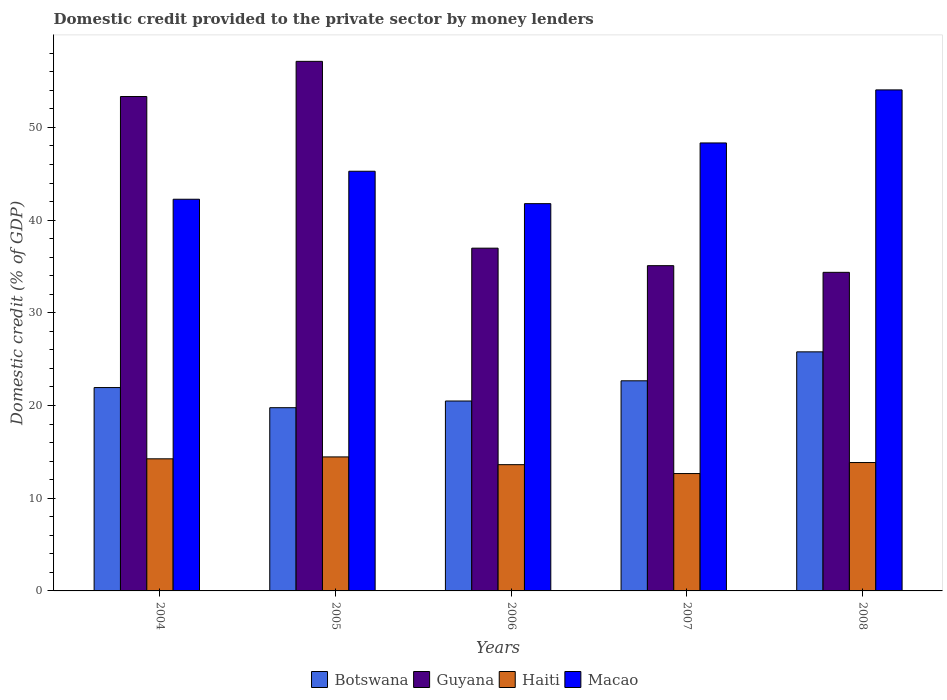How many different coloured bars are there?
Give a very brief answer. 4. Are the number of bars on each tick of the X-axis equal?
Your answer should be compact. Yes. How many bars are there on the 5th tick from the left?
Offer a terse response. 4. In how many cases, is the number of bars for a given year not equal to the number of legend labels?
Provide a succinct answer. 0. What is the domestic credit provided to the private sector by money lenders in Guyana in 2008?
Your response must be concise. 34.36. Across all years, what is the maximum domestic credit provided to the private sector by money lenders in Macao?
Offer a terse response. 54.04. Across all years, what is the minimum domestic credit provided to the private sector by money lenders in Botswana?
Provide a succinct answer. 19.76. In which year was the domestic credit provided to the private sector by money lenders in Guyana maximum?
Make the answer very short. 2005. What is the total domestic credit provided to the private sector by money lenders in Botswana in the graph?
Provide a succinct answer. 110.64. What is the difference between the domestic credit provided to the private sector by money lenders in Guyana in 2007 and that in 2008?
Your response must be concise. 0.72. What is the difference between the domestic credit provided to the private sector by money lenders in Macao in 2008 and the domestic credit provided to the private sector by money lenders in Guyana in 2004?
Provide a succinct answer. 0.71. What is the average domestic credit provided to the private sector by money lenders in Guyana per year?
Your answer should be compact. 43.37. In the year 2008, what is the difference between the domestic credit provided to the private sector by money lenders in Macao and domestic credit provided to the private sector by money lenders in Botswana?
Provide a short and direct response. 28.26. What is the ratio of the domestic credit provided to the private sector by money lenders in Botswana in 2005 to that in 2008?
Give a very brief answer. 0.77. Is the domestic credit provided to the private sector by money lenders in Botswana in 2005 less than that in 2007?
Ensure brevity in your answer.  Yes. What is the difference between the highest and the second highest domestic credit provided to the private sector by money lenders in Haiti?
Provide a succinct answer. 0.21. What is the difference between the highest and the lowest domestic credit provided to the private sector by money lenders in Guyana?
Offer a very short reply. 22.76. Is the sum of the domestic credit provided to the private sector by money lenders in Macao in 2004 and 2005 greater than the maximum domestic credit provided to the private sector by money lenders in Guyana across all years?
Your response must be concise. Yes. What does the 4th bar from the left in 2005 represents?
Your answer should be compact. Macao. What does the 2nd bar from the right in 2006 represents?
Give a very brief answer. Haiti. How many bars are there?
Give a very brief answer. 20. Are all the bars in the graph horizontal?
Your response must be concise. No. How many years are there in the graph?
Your answer should be very brief. 5. What is the difference between two consecutive major ticks on the Y-axis?
Make the answer very short. 10. Does the graph contain any zero values?
Keep it short and to the point. No. Does the graph contain grids?
Your answer should be compact. No. Where does the legend appear in the graph?
Provide a succinct answer. Bottom center. What is the title of the graph?
Offer a terse response. Domestic credit provided to the private sector by money lenders. Does "Samoa" appear as one of the legend labels in the graph?
Make the answer very short. No. What is the label or title of the X-axis?
Give a very brief answer. Years. What is the label or title of the Y-axis?
Your response must be concise. Domestic credit (% of GDP). What is the Domestic credit (% of GDP) in Botswana in 2004?
Offer a very short reply. 21.94. What is the Domestic credit (% of GDP) of Guyana in 2004?
Your answer should be very brief. 53.33. What is the Domestic credit (% of GDP) of Haiti in 2004?
Offer a very short reply. 14.25. What is the Domestic credit (% of GDP) of Macao in 2004?
Offer a terse response. 42.25. What is the Domestic credit (% of GDP) in Botswana in 2005?
Give a very brief answer. 19.76. What is the Domestic credit (% of GDP) in Guyana in 2005?
Give a very brief answer. 57.12. What is the Domestic credit (% of GDP) in Haiti in 2005?
Provide a succinct answer. 14.45. What is the Domestic credit (% of GDP) in Macao in 2005?
Provide a short and direct response. 45.27. What is the Domestic credit (% of GDP) in Botswana in 2006?
Keep it short and to the point. 20.48. What is the Domestic credit (% of GDP) in Guyana in 2006?
Give a very brief answer. 36.97. What is the Domestic credit (% of GDP) of Haiti in 2006?
Offer a very short reply. 13.62. What is the Domestic credit (% of GDP) of Macao in 2006?
Your response must be concise. 41.77. What is the Domestic credit (% of GDP) in Botswana in 2007?
Give a very brief answer. 22.66. What is the Domestic credit (% of GDP) of Guyana in 2007?
Ensure brevity in your answer.  35.08. What is the Domestic credit (% of GDP) of Haiti in 2007?
Provide a short and direct response. 12.66. What is the Domestic credit (% of GDP) of Macao in 2007?
Your response must be concise. 48.32. What is the Domestic credit (% of GDP) in Botswana in 2008?
Provide a short and direct response. 25.79. What is the Domestic credit (% of GDP) in Guyana in 2008?
Offer a very short reply. 34.36. What is the Domestic credit (% of GDP) of Haiti in 2008?
Your response must be concise. 13.85. What is the Domestic credit (% of GDP) of Macao in 2008?
Provide a succinct answer. 54.04. Across all years, what is the maximum Domestic credit (% of GDP) in Botswana?
Ensure brevity in your answer.  25.79. Across all years, what is the maximum Domestic credit (% of GDP) in Guyana?
Your answer should be very brief. 57.12. Across all years, what is the maximum Domestic credit (% of GDP) in Haiti?
Your response must be concise. 14.45. Across all years, what is the maximum Domestic credit (% of GDP) in Macao?
Make the answer very short. 54.04. Across all years, what is the minimum Domestic credit (% of GDP) of Botswana?
Keep it short and to the point. 19.76. Across all years, what is the minimum Domestic credit (% of GDP) of Guyana?
Your response must be concise. 34.36. Across all years, what is the minimum Domestic credit (% of GDP) of Haiti?
Your answer should be very brief. 12.66. Across all years, what is the minimum Domestic credit (% of GDP) of Macao?
Offer a terse response. 41.77. What is the total Domestic credit (% of GDP) in Botswana in the graph?
Make the answer very short. 110.64. What is the total Domestic credit (% of GDP) in Guyana in the graph?
Give a very brief answer. 216.87. What is the total Domestic credit (% of GDP) in Haiti in the graph?
Your response must be concise. 68.83. What is the total Domestic credit (% of GDP) of Macao in the graph?
Your response must be concise. 231.66. What is the difference between the Domestic credit (% of GDP) in Botswana in 2004 and that in 2005?
Your response must be concise. 2.17. What is the difference between the Domestic credit (% of GDP) of Guyana in 2004 and that in 2005?
Make the answer very short. -3.79. What is the difference between the Domestic credit (% of GDP) of Haiti in 2004 and that in 2005?
Your answer should be compact. -0.21. What is the difference between the Domestic credit (% of GDP) of Macao in 2004 and that in 2005?
Your response must be concise. -3.02. What is the difference between the Domestic credit (% of GDP) in Botswana in 2004 and that in 2006?
Your answer should be compact. 1.45. What is the difference between the Domestic credit (% of GDP) of Guyana in 2004 and that in 2006?
Provide a short and direct response. 16.36. What is the difference between the Domestic credit (% of GDP) in Haiti in 2004 and that in 2006?
Your answer should be very brief. 0.63. What is the difference between the Domestic credit (% of GDP) in Macao in 2004 and that in 2006?
Make the answer very short. 0.48. What is the difference between the Domestic credit (% of GDP) in Botswana in 2004 and that in 2007?
Your answer should be very brief. -0.73. What is the difference between the Domestic credit (% of GDP) of Guyana in 2004 and that in 2007?
Provide a succinct answer. 18.25. What is the difference between the Domestic credit (% of GDP) of Haiti in 2004 and that in 2007?
Your answer should be very brief. 1.59. What is the difference between the Domestic credit (% of GDP) of Macao in 2004 and that in 2007?
Offer a very short reply. -6.07. What is the difference between the Domestic credit (% of GDP) of Botswana in 2004 and that in 2008?
Your answer should be compact. -3.85. What is the difference between the Domestic credit (% of GDP) of Guyana in 2004 and that in 2008?
Give a very brief answer. 18.97. What is the difference between the Domestic credit (% of GDP) in Haiti in 2004 and that in 2008?
Your answer should be compact. 0.4. What is the difference between the Domestic credit (% of GDP) in Macao in 2004 and that in 2008?
Your answer should be compact. -11.79. What is the difference between the Domestic credit (% of GDP) of Botswana in 2005 and that in 2006?
Provide a succinct answer. -0.72. What is the difference between the Domestic credit (% of GDP) in Guyana in 2005 and that in 2006?
Your answer should be compact. 20.15. What is the difference between the Domestic credit (% of GDP) of Haiti in 2005 and that in 2006?
Give a very brief answer. 0.84. What is the difference between the Domestic credit (% of GDP) in Macao in 2005 and that in 2006?
Make the answer very short. 3.5. What is the difference between the Domestic credit (% of GDP) in Botswana in 2005 and that in 2007?
Provide a short and direct response. -2.9. What is the difference between the Domestic credit (% of GDP) in Guyana in 2005 and that in 2007?
Make the answer very short. 22.04. What is the difference between the Domestic credit (% of GDP) in Haiti in 2005 and that in 2007?
Your response must be concise. 1.8. What is the difference between the Domestic credit (% of GDP) of Macao in 2005 and that in 2007?
Provide a succinct answer. -3.05. What is the difference between the Domestic credit (% of GDP) in Botswana in 2005 and that in 2008?
Offer a very short reply. -6.02. What is the difference between the Domestic credit (% of GDP) in Guyana in 2005 and that in 2008?
Keep it short and to the point. 22.76. What is the difference between the Domestic credit (% of GDP) in Haiti in 2005 and that in 2008?
Give a very brief answer. 0.61. What is the difference between the Domestic credit (% of GDP) of Macao in 2005 and that in 2008?
Provide a short and direct response. -8.77. What is the difference between the Domestic credit (% of GDP) of Botswana in 2006 and that in 2007?
Your answer should be compact. -2.18. What is the difference between the Domestic credit (% of GDP) in Guyana in 2006 and that in 2007?
Your answer should be very brief. 1.89. What is the difference between the Domestic credit (% of GDP) in Haiti in 2006 and that in 2007?
Offer a very short reply. 0.96. What is the difference between the Domestic credit (% of GDP) of Macao in 2006 and that in 2007?
Make the answer very short. -6.55. What is the difference between the Domestic credit (% of GDP) of Botswana in 2006 and that in 2008?
Keep it short and to the point. -5.3. What is the difference between the Domestic credit (% of GDP) of Guyana in 2006 and that in 2008?
Offer a terse response. 2.61. What is the difference between the Domestic credit (% of GDP) in Haiti in 2006 and that in 2008?
Give a very brief answer. -0.23. What is the difference between the Domestic credit (% of GDP) of Macao in 2006 and that in 2008?
Your answer should be compact. -12.27. What is the difference between the Domestic credit (% of GDP) of Botswana in 2007 and that in 2008?
Provide a short and direct response. -3.12. What is the difference between the Domestic credit (% of GDP) in Guyana in 2007 and that in 2008?
Offer a terse response. 0.72. What is the difference between the Domestic credit (% of GDP) of Haiti in 2007 and that in 2008?
Your response must be concise. -1.19. What is the difference between the Domestic credit (% of GDP) of Macao in 2007 and that in 2008?
Provide a short and direct response. -5.72. What is the difference between the Domestic credit (% of GDP) of Botswana in 2004 and the Domestic credit (% of GDP) of Guyana in 2005?
Keep it short and to the point. -35.19. What is the difference between the Domestic credit (% of GDP) of Botswana in 2004 and the Domestic credit (% of GDP) of Haiti in 2005?
Give a very brief answer. 7.48. What is the difference between the Domestic credit (% of GDP) in Botswana in 2004 and the Domestic credit (% of GDP) in Macao in 2005?
Make the answer very short. -23.33. What is the difference between the Domestic credit (% of GDP) of Guyana in 2004 and the Domestic credit (% of GDP) of Haiti in 2005?
Provide a succinct answer. 38.87. What is the difference between the Domestic credit (% of GDP) in Guyana in 2004 and the Domestic credit (% of GDP) in Macao in 2005?
Keep it short and to the point. 8.06. What is the difference between the Domestic credit (% of GDP) in Haiti in 2004 and the Domestic credit (% of GDP) in Macao in 2005?
Give a very brief answer. -31.02. What is the difference between the Domestic credit (% of GDP) of Botswana in 2004 and the Domestic credit (% of GDP) of Guyana in 2006?
Your answer should be compact. -15.04. What is the difference between the Domestic credit (% of GDP) in Botswana in 2004 and the Domestic credit (% of GDP) in Haiti in 2006?
Make the answer very short. 8.32. What is the difference between the Domestic credit (% of GDP) of Botswana in 2004 and the Domestic credit (% of GDP) of Macao in 2006?
Ensure brevity in your answer.  -19.84. What is the difference between the Domestic credit (% of GDP) of Guyana in 2004 and the Domestic credit (% of GDP) of Haiti in 2006?
Give a very brief answer. 39.71. What is the difference between the Domestic credit (% of GDP) in Guyana in 2004 and the Domestic credit (% of GDP) in Macao in 2006?
Give a very brief answer. 11.56. What is the difference between the Domestic credit (% of GDP) of Haiti in 2004 and the Domestic credit (% of GDP) of Macao in 2006?
Offer a very short reply. -27.52. What is the difference between the Domestic credit (% of GDP) of Botswana in 2004 and the Domestic credit (% of GDP) of Guyana in 2007?
Provide a short and direct response. -13.15. What is the difference between the Domestic credit (% of GDP) in Botswana in 2004 and the Domestic credit (% of GDP) in Haiti in 2007?
Your answer should be very brief. 9.28. What is the difference between the Domestic credit (% of GDP) in Botswana in 2004 and the Domestic credit (% of GDP) in Macao in 2007?
Offer a terse response. -26.39. What is the difference between the Domestic credit (% of GDP) of Guyana in 2004 and the Domestic credit (% of GDP) of Haiti in 2007?
Make the answer very short. 40.67. What is the difference between the Domestic credit (% of GDP) in Guyana in 2004 and the Domestic credit (% of GDP) in Macao in 2007?
Keep it short and to the point. 5.01. What is the difference between the Domestic credit (% of GDP) in Haiti in 2004 and the Domestic credit (% of GDP) in Macao in 2007?
Offer a terse response. -34.07. What is the difference between the Domestic credit (% of GDP) in Botswana in 2004 and the Domestic credit (% of GDP) in Guyana in 2008?
Your response must be concise. -12.43. What is the difference between the Domestic credit (% of GDP) in Botswana in 2004 and the Domestic credit (% of GDP) in Haiti in 2008?
Your response must be concise. 8.09. What is the difference between the Domestic credit (% of GDP) in Botswana in 2004 and the Domestic credit (% of GDP) in Macao in 2008?
Offer a terse response. -32.11. What is the difference between the Domestic credit (% of GDP) in Guyana in 2004 and the Domestic credit (% of GDP) in Haiti in 2008?
Provide a short and direct response. 39.48. What is the difference between the Domestic credit (% of GDP) in Guyana in 2004 and the Domestic credit (% of GDP) in Macao in 2008?
Offer a terse response. -0.71. What is the difference between the Domestic credit (% of GDP) of Haiti in 2004 and the Domestic credit (% of GDP) of Macao in 2008?
Make the answer very short. -39.79. What is the difference between the Domestic credit (% of GDP) in Botswana in 2005 and the Domestic credit (% of GDP) in Guyana in 2006?
Make the answer very short. -17.21. What is the difference between the Domestic credit (% of GDP) in Botswana in 2005 and the Domestic credit (% of GDP) in Haiti in 2006?
Ensure brevity in your answer.  6.14. What is the difference between the Domestic credit (% of GDP) of Botswana in 2005 and the Domestic credit (% of GDP) of Macao in 2006?
Offer a terse response. -22.01. What is the difference between the Domestic credit (% of GDP) of Guyana in 2005 and the Domestic credit (% of GDP) of Haiti in 2006?
Ensure brevity in your answer.  43.5. What is the difference between the Domestic credit (% of GDP) of Guyana in 2005 and the Domestic credit (% of GDP) of Macao in 2006?
Make the answer very short. 15.35. What is the difference between the Domestic credit (% of GDP) of Haiti in 2005 and the Domestic credit (% of GDP) of Macao in 2006?
Offer a terse response. -27.32. What is the difference between the Domestic credit (% of GDP) in Botswana in 2005 and the Domestic credit (% of GDP) in Guyana in 2007?
Your answer should be compact. -15.32. What is the difference between the Domestic credit (% of GDP) in Botswana in 2005 and the Domestic credit (% of GDP) in Haiti in 2007?
Keep it short and to the point. 7.1. What is the difference between the Domestic credit (% of GDP) in Botswana in 2005 and the Domestic credit (% of GDP) in Macao in 2007?
Provide a succinct answer. -28.56. What is the difference between the Domestic credit (% of GDP) in Guyana in 2005 and the Domestic credit (% of GDP) in Haiti in 2007?
Keep it short and to the point. 44.46. What is the difference between the Domestic credit (% of GDP) in Guyana in 2005 and the Domestic credit (% of GDP) in Macao in 2007?
Ensure brevity in your answer.  8.8. What is the difference between the Domestic credit (% of GDP) in Haiti in 2005 and the Domestic credit (% of GDP) in Macao in 2007?
Your response must be concise. -33.87. What is the difference between the Domestic credit (% of GDP) of Botswana in 2005 and the Domestic credit (% of GDP) of Guyana in 2008?
Ensure brevity in your answer.  -14.6. What is the difference between the Domestic credit (% of GDP) of Botswana in 2005 and the Domestic credit (% of GDP) of Haiti in 2008?
Your answer should be compact. 5.92. What is the difference between the Domestic credit (% of GDP) of Botswana in 2005 and the Domestic credit (% of GDP) of Macao in 2008?
Your response must be concise. -34.28. What is the difference between the Domestic credit (% of GDP) of Guyana in 2005 and the Domestic credit (% of GDP) of Haiti in 2008?
Your response must be concise. 43.28. What is the difference between the Domestic credit (% of GDP) of Guyana in 2005 and the Domestic credit (% of GDP) of Macao in 2008?
Provide a short and direct response. 3.08. What is the difference between the Domestic credit (% of GDP) of Haiti in 2005 and the Domestic credit (% of GDP) of Macao in 2008?
Your response must be concise. -39.59. What is the difference between the Domestic credit (% of GDP) in Botswana in 2006 and the Domestic credit (% of GDP) in Guyana in 2007?
Make the answer very short. -14.6. What is the difference between the Domestic credit (% of GDP) of Botswana in 2006 and the Domestic credit (% of GDP) of Haiti in 2007?
Provide a short and direct response. 7.82. What is the difference between the Domestic credit (% of GDP) of Botswana in 2006 and the Domestic credit (% of GDP) of Macao in 2007?
Offer a very short reply. -27.84. What is the difference between the Domestic credit (% of GDP) of Guyana in 2006 and the Domestic credit (% of GDP) of Haiti in 2007?
Ensure brevity in your answer.  24.31. What is the difference between the Domestic credit (% of GDP) in Guyana in 2006 and the Domestic credit (% of GDP) in Macao in 2007?
Keep it short and to the point. -11.35. What is the difference between the Domestic credit (% of GDP) in Haiti in 2006 and the Domestic credit (% of GDP) in Macao in 2007?
Offer a very short reply. -34.7. What is the difference between the Domestic credit (% of GDP) of Botswana in 2006 and the Domestic credit (% of GDP) of Guyana in 2008?
Ensure brevity in your answer.  -13.88. What is the difference between the Domestic credit (% of GDP) of Botswana in 2006 and the Domestic credit (% of GDP) of Haiti in 2008?
Offer a terse response. 6.64. What is the difference between the Domestic credit (% of GDP) in Botswana in 2006 and the Domestic credit (% of GDP) in Macao in 2008?
Your answer should be very brief. -33.56. What is the difference between the Domestic credit (% of GDP) of Guyana in 2006 and the Domestic credit (% of GDP) of Haiti in 2008?
Your response must be concise. 23.13. What is the difference between the Domestic credit (% of GDP) of Guyana in 2006 and the Domestic credit (% of GDP) of Macao in 2008?
Provide a succinct answer. -17.07. What is the difference between the Domestic credit (% of GDP) in Haiti in 2006 and the Domestic credit (% of GDP) in Macao in 2008?
Make the answer very short. -40.42. What is the difference between the Domestic credit (% of GDP) of Botswana in 2007 and the Domestic credit (% of GDP) of Guyana in 2008?
Your answer should be compact. -11.7. What is the difference between the Domestic credit (% of GDP) of Botswana in 2007 and the Domestic credit (% of GDP) of Haiti in 2008?
Keep it short and to the point. 8.82. What is the difference between the Domestic credit (% of GDP) in Botswana in 2007 and the Domestic credit (% of GDP) in Macao in 2008?
Your answer should be compact. -31.38. What is the difference between the Domestic credit (% of GDP) of Guyana in 2007 and the Domestic credit (% of GDP) of Haiti in 2008?
Provide a short and direct response. 21.24. What is the difference between the Domestic credit (% of GDP) of Guyana in 2007 and the Domestic credit (% of GDP) of Macao in 2008?
Your response must be concise. -18.96. What is the difference between the Domestic credit (% of GDP) in Haiti in 2007 and the Domestic credit (% of GDP) in Macao in 2008?
Your answer should be compact. -41.38. What is the average Domestic credit (% of GDP) of Botswana per year?
Provide a short and direct response. 22.13. What is the average Domestic credit (% of GDP) of Guyana per year?
Your answer should be compact. 43.37. What is the average Domestic credit (% of GDP) in Haiti per year?
Ensure brevity in your answer.  13.77. What is the average Domestic credit (% of GDP) of Macao per year?
Your answer should be very brief. 46.33. In the year 2004, what is the difference between the Domestic credit (% of GDP) of Botswana and Domestic credit (% of GDP) of Guyana?
Your answer should be very brief. -31.39. In the year 2004, what is the difference between the Domestic credit (% of GDP) in Botswana and Domestic credit (% of GDP) in Haiti?
Provide a succinct answer. 7.69. In the year 2004, what is the difference between the Domestic credit (% of GDP) of Botswana and Domestic credit (% of GDP) of Macao?
Make the answer very short. -20.31. In the year 2004, what is the difference between the Domestic credit (% of GDP) in Guyana and Domestic credit (% of GDP) in Haiti?
Offer a terse response. 39.08. In the year 2004, what is the difference between the Domestic credit (% of GDP) of Guyana and Domestic credit (% of GDP) of Macao?
Provide a succinct answer. 11.08. In the year 2004, what is the difference between the Domestic credit (% of GDP) in Haiti and Domestic credit (% of GDP) in Macao?
Provide a succinct answer. -28. In the year 2005, what is the difference between the Domestic credit (% of GDP) of Botswana and Domestic credit (% of GDP) of Guyana?
Offer a terse response. -37.36. In the year 2005, what is the difference between the Domestic credit (% of GDP) in Botswana and Domestic credit (% of GDP) in Haiti?
Make the answer very short. 5.31. In the year 2005, what is the difference between the Domestic credit (% of GDP) of Botswana and Domestic credit (% of GDP) of Macao?
Offer a very short reply. -25.51. In the year 2005, what is the difference between the Domestic credit (% of GDP) in Guyana and Domestic credit (% of GDP) in Haiti?
Provide a succinct answer. 42.67. In the year 2005, what is the difference between the Domestic credit (% of GDP) of Guyana and Domestic credit (% of GDP) of Macao?
Give a very brief answer. 11.85. In the year 2005, what is the difference between the Domestic credit (% of GDP) in Haiti and Domestic credit (% of GDP) in Macao?
Give a very brief answer. -30.81. In the year 2006, what is the difference between the Domestic credit (% of GDP) in Botswana and Domestic credit (% of GDP) in Guyana?
Your response must be concise. -16.49. In the year 2006, what is the difference between the Domestic credit (% of GDP) of Botswana and Domestic credit (% of GDP) of Haiti?
Provide a short and direct response. 6.87. In the year 2006, what is the difference between the Domestic credit (% of GDP) in Botswana and Domestic credit (% of GDP) in Macao?
Your answer should be compact. -21.29. In the year 2006, what is the difference between the Domestic credit (% of GDP) in Guyana and Domestic credit (% of GDP) in Haiti?
Your answer should be compact. 23.35. In the year 2006, what is the difference between the Domestic credit (% of GDP) in Guyana and Domestic credit (% of GDP) in Macao?
Provide a short and direct response. -4.8. In the year 2006, what is the difference between the Domestic credit (% of GDP) in Haiti and Domestic credit (% of GDP) in Macao?
Your response must be concise. -28.15. In the year 2007, what is the difference between the Domestic credit (% of GDP) in Botswana and Domestic credit (% of GDP) in Guyana?
Make the answer very short. -12.42. In the year 2007, what is the difference between the Domestic credit (% of GDP) in Botswana and Domestic credit (% of GDP) in Haiti?
Provide a succinct answer. 10. In the year 2007, what is the difference between the Domestic credit (% of GDP) in Botswana and Domestic credit (% of GDP) in Macao?
Ensure brevity in your answer.  -25.66. In the year 2007, what is the difference between the Domestic credit (% of GDP) of Guyana and Domestic credit (% of GDP) of Haiti?
Offer a very short reply. 22.42. In the year 2007, what is the difference between the Domestic credit (% of GDP) in Guyana and Domestic credit (% of GDP) in Macao?
Provide a short and direct response. -13.24. In the year 2007, what is the difference between the Domestic credit (% of GDP) in Haiti and Domestic credit (% of GDP) in Macao?
Provide a succinct answer. -35.66. In the year 2008, what is the difference between the Domestic credit (% of GDP) of Botswana and Domestic credit (% of GDP) of Guyana?
Your response must be concise. -8.58. In the year 2008, what is the difference between the Domestic credit (% of GDP) of Botswana and Domestic credit (% of GDP) of Haiti?
Keep it short and to the point. 11.94. In the year 2008, what is the difference between the Domestic credit (% of GDP) in Botswana and Domestic credit (% of GDP) in Macao?
Provide a succinct answer. -28.26. In the year 2008, what is the difference between the Domestic credit (% of GDP) in Guyana and Domestic credit (% of GDP) in Haiti?
Your answer should be compact. 20.52. In the year 2008, what is the difference between the Domestic credit (% of GDP) in Guyana and Domestic credit (% of GDP) in Macao?
Make the answer very short. -19.68. In the year 2008, what is the difference between the Domestic credit (% of GDP) in Haiti and Domestic credit (% of GDP) in Macao?
Provide a short and direct response. -40.2. What is the ratio of the Domestic credit (% of GDP) in Botswana in 2004 to that in 2005?
Your answer should be compact. 1.11. What is the ratio of the Domestic credit (% of GDP) in Guyana in 2004 to that in 2005?
Your answer should be very brief. 0.93. What is the ratio of the Domestic credit (% of GDP) of Haiti in 2004 to that in 2005?
Ensure brevity in your answer.  0.99. What is the ratio of the Domestic credit (% of GDP) in Botswana in 2004 to that in 2006?
Give a very brief answer. 1.07. What is the ratio of the Domestic credit (% of GDP) of Guyana in 2004 to that in 2006?
Your answer should be very brief. 1.44. What is the ratio of the Domestic credit (% of GDP) in Haiti in 2004 to that in 2006?
Make the answer very short. 1.05. What is the ratio of the Domestic credit (% of GDP) of Macao in 2004 to that in 2006?
Provide a succinct answer. 1.01. What is the ratio of the Domestic credit (% of GDP) of Botswana in 2004 to that in 2007?
Offer a terse response. 0.97. What is the ratio of the Domestic credit (% of GDP) in Guyana in 2004 to that in 2007?
Your answer should be very brief. 1.52. What is the ratio of the Domestic credit (% of GDP) of Haiti in 2004 to that in 2007?
Ensure brevity in your answer.  1.13. What is the ratio of the Domestic credit (% of GDP) of Macao in 2004 to that in 2007?
Keep it short and to the point. 0.87. What is the ratio of the Domestic credit (% of GDP) of Botswana in 2004 to that in 2008?
Offer a very short reply. 0.85. What is the ratio of the Domestic credit (% of GDP) in Guyana in 2004 to that in 2008?
Provide a short and direct response. 1.55. What is the ratio of the Domestic credit (% of GDP) in Haiti in 2004 to that in 2008?
Your answer should be very brief. 1.03. What is the ratio of the Domestic credit (% of GDP) in Macao in 2004 to that in 2008?
Offer a terse response. 0.78. What is the ratio of the Domestic credit (% of GDP) of Botswana in 2005 to that in 2006?
Keep it short and to the point. 0.96. What is the ratio of the Domestic credit (% of GDP) in Guyana in 2005 to that in 2006?
Give a very brief answer. 1.54. What is the ratio of the Domestic credit (% of GDP) of Haiti in 2005 to that in 2006?
Keep it short and to the point. 1.06. What is the ratio of the Domestic credit (% of GDP) in Macao in 2005 to that in 2006?
Your response must be concise. 1.08. What is the ratio of the Domestic credit (% of GDP) of Botswana in 2005 to that in 2007?
Provide a succinct answer. 0.87. What is the ratio of the Domestic credit (% of GDP) in Guyana in 2005 to that in 2007?
Provide a short and direct response. 1.63. What is the ratio of the Domestic credit (% of GDP) in Haiti in 2005 to that in 2007?
Provide a succinct answer. 1.14. What is the ratio of the Domestic credit (% of GDP) in Macao in 2005 to that in 2007?
Keep it short and to the point. 0.94. What is the ratio of the Domestic credit (% of GDP) of Botswana in 2005 to that in 2008?
Your answer should be very brief. 0.77. What is the ratio of the Domestic credit (% of GDP) in Guyana in 2005 to that in 2008?
Your answer should be compact. 1.66. What is the ratio of the Domestic credit (% of GDP) of Haiti in 2005 to that in 2008?
Offer a very short reply. 1.04. What is the ratio of the Domestic credit (% of GDP) in Macao in 2005 to that in 2008?
Provide a succinct answer. 0.84. What is the ratio of the Domestic credit (% of GDP) of Botswana in 2006 to that in 2007?
Offer a very short reply. 0.9. What is the ratio of the Domestic credit (% of GDP) of Guyana in 2006 to that in 2007?
Offer a very short reply. 1.05. What is the ratio of the Domestic credit (% of GDP) in Haiti in 2006 to that in 2007?
Keep it short and to the point. 1.08. What is the ratio of the Domestic credit (% of GDP) of Macao in 2006 to that in 2007?
Ensure brevity in your answer.  0.86. What is the ratio of the Domestic credit (% of GDP) in Botswana in 2006 to that in 2008?
Provide a succinct answer. 0.79. What is the ratio of the Domestic credit (% of GDP) of Guyana in 2006 to that in 2008?
Make the answer very short. 1.08. What is the ratio of the Domestic credit (% of GDP) in Haiti in 2006 to that in 2008?
Your answer should be very brief. 0.98. What is the ratio of the Domestic credit (% of GDP) in Macao in 2006 to that in 2008?
Make the answer very short. 0.77. What is the ratio of the Domestic credit (% of GDP) in Botswana in 2007 to that in 2008?
Keep it short and to the point. 0.88. What is the ratio of the Domestic credit (% of GDP) in Guyana in 2007 to that in 2008?
Your response must be concise. 1.02. What is the ratio of the Domestic credit (% of GDP) of Haiti in 2007 to that in 2008?
Your answer should be compact. 0.91. What is the ratio of the Domestic credit (% of GDP) in Macao in 2007 to that in 2008?
Give a very brief answer. 0.89. What is the difference between the highest and the second highest Domestic credit (% of GDP) of Botswana?
Make the answer very short. 3.12. What is the difference between the highest and the second highest Domestic credit (% of GDP) in Guyana?
Provide a succinct answer. 3.79. What is the difference between the highest and the second highest Domestic credit (% of GDP) in Haiti?
Make the answer very short. 0.21. What is the difference between the highest and the second highest Domestic credit (% of GDP) of Macao?
Your response must be concise. 5.72. What is the difference between the highest and the lowest Domestic credit (% of GDP) in Botswana?
Provide a succinct answer. 6.02. What is the difference between the highest and the lowest Domestic credit (% of GDP) of Guyana?
Your answer should be compact. 22.76. What is the difference between the highest and the lowest Domestic credit (% of GDP) of Haiti?
Your answer should be compact. 1.8. What is the difference between the highest and the lowest Domestic credit (% of GDP) of Macao?
Provide a short and direct response. 12.27. 